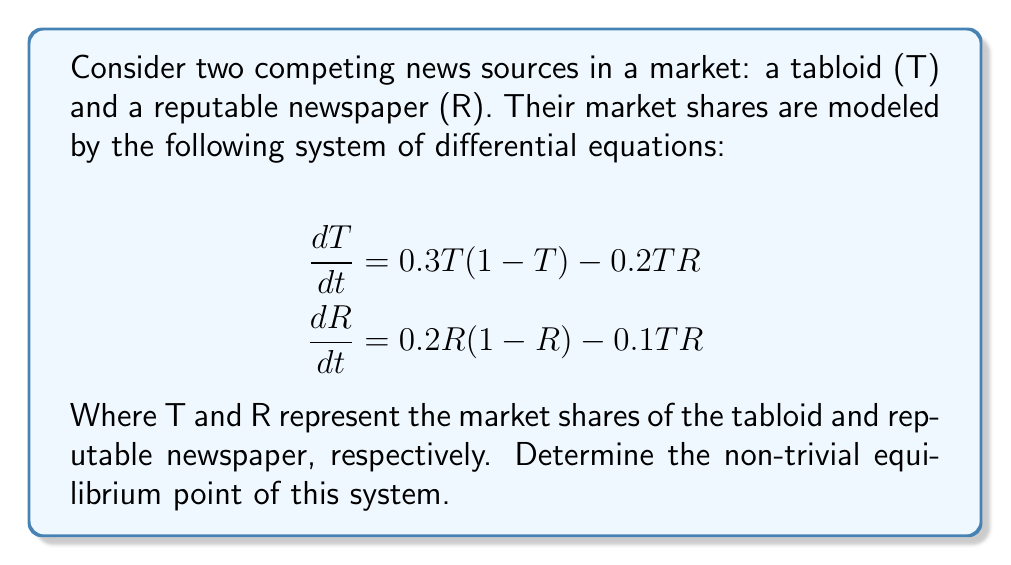Can you solve this math problem? To find the equilibrium point, we set both equations equal to zero and solve for T and R:

1) Set $\frac{dT}{dt} = 0$ and $\frac{dR}{dt} = 0$:

   $$\begin{align}
   0 &= 0.3T(1-T) - 0.2TR \\
   0 &= 0.2R(1-R) - 0.1TR
   \end{align}$$

2) From the first equation:
   
   $0.3T(1-T) = 0.2TR$
   $0.3 - 0.3T = 0.2R$
   $R = 1.5 - 1.5T$

3) Substitute this into the second equation:

   $0 = 0.2(1.5-1.5T)(1-(1.5-1.5T)) - 0.1T(1.5-1.5T)$

4) Simplify:

   $0 = 0.3(1-T)(1-1.5+1.5T) - 0.15T(1-T)$
   $0 = 0.3(1-T)(-0.5+1.5T) - 0.15T(1-T)$
   $0 = -0.15(1-T) + 0.45T(1-T) - 0.15T(1-T)$
   $0 = -0.15 + 0.15T + 0.45T - 0.45T^2 - 0.15T + 0.15T^2$
   $0 = -0.15 + 0.45T - 0.3T^2$

5) Solve this quadratic equation:

   $0.3T^2 - 0.45T + 0.15 = 0$
   $T^2 - 1.5T + 0.5 = 0$
   $(T - 0.5)(T - 1) = 0$

   $T = 0.5$ (since T = 1 is trivial)

6) Substitute back to find R:

   $R = 1.5 - 1.5(0.5) = 0.75$

Therefore, the non-trivial equilibrium point is (0.5, 0.75).
Answer: (0.5, 0.75) 